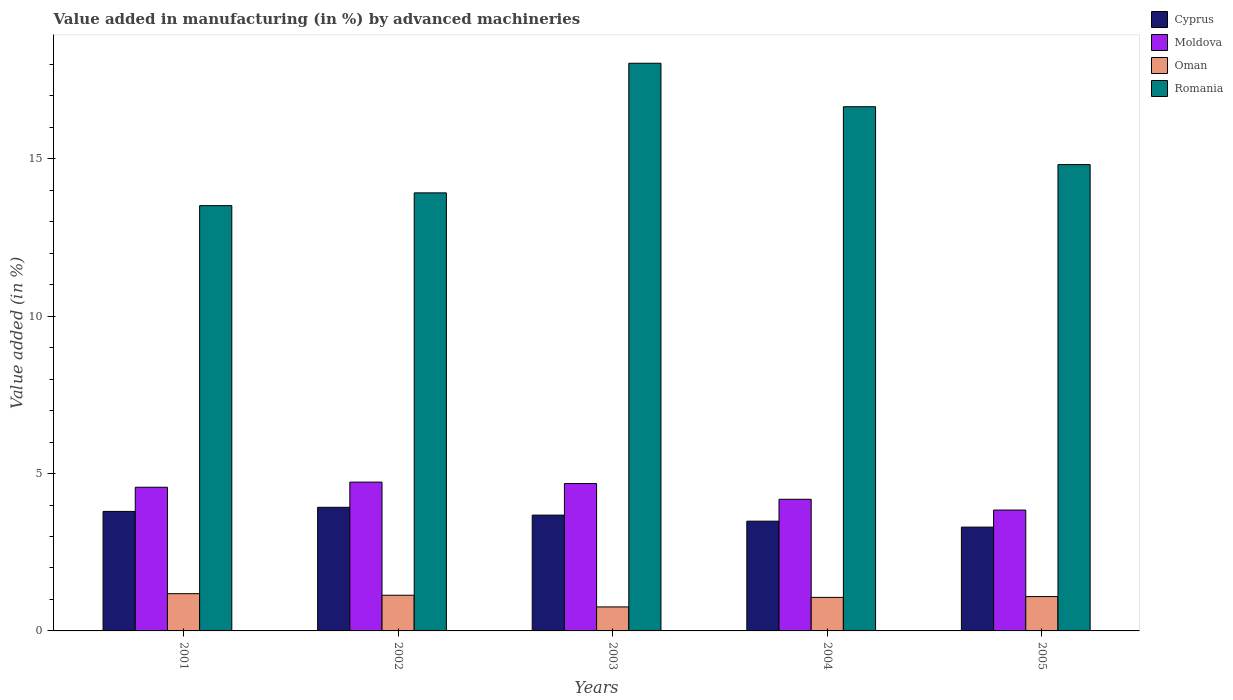How many different coloured bars are there?
Your answer should be compact. 4. Are the number of bars on each tick of the X-axis equal?
Your answer should be compact. Yes. How many bars are there on the 4th tick from the right?
Give a very brief answer. 4. What is the label of the 2nd group of bars from the left?
Offer a terse response. 2002. In how many cases, is the number of bars for a given year not equal to the number of legend labels?
Give a very brief answer. 0. What is the percentage of value added in manufacturing by advanced machineries in Romania in 2003?
Your answer should be very brief. 18.04. Across all years, what is the maximum percentage of value added in manufacturing by advanced machineries in Cyprus?
Give a very brief answer. 3.93. Across all years, what is the minimum percentage of value added in manufacturing by advanced machineries in Romania?
Provide a short and direct response. 13.51. In which year was the percentage of value added in manufacturing by advanced machineries in Cyprus minimum?
Ensure brevity in your answer.  2005. What is the total percentage of value added in manufacturing by advanced machineries in Moldova in the graph?
Make the answer very short. 22. What is the difference between the percentage of value added in manufacturing by advanced machineries in Moldova in 2004 and that in 2005?
Offer a very short reply. 0.34. What is the difference between the percentage of value added in manufacturing by advanced machineries in Oman in 2005 and the percentage of value added in manufacturing by advanced machineries in Moldova in 2001?
Your response must be concise. -3.47. What is the average percentage of value added in manufacturing by advanced machineries in Oman per year?
Give a very brief answer. 1.05. In the year 2004, what is the difference between the percentage of value added in manufacturing by advanced machineries in Moldova and percentage of value added in manufacturing by advanced machineries in Romania?
Your response must be concise. -12.47. In how many years, is the percentage of value added in manufacturing by advanced machineries in Moldova greater than 1 %?
Your response must be concise. 5. What is the ratio of the percentage of value added in manufacturing by advanced machineries in Moldova in 2003 to that in 2004?
Keep it short and to the point. 1.12. Is the percentage of value added in manufacturing by advanced machineries in Oman in 2001 less than that in 2003?
Provide a succinct answer. No. What is the difference between the highest and the second highest percentage of value added in manufacturing by advanced machineries in Romania?
Your answer should be compact. 1.38. What is the difference between the highest and the lowest percentage of value added in manufacturing by advanced machineries in Oman?
Provide a short and direct response. 0.42. In how many years, is the percentage of value added in manufacturing by advanced machineries in Oman greater than the average percentage of value added in manufacturing by advanced machineries in Oman taken over all years?
Provide a short and direct response. 4. Is the sum of the percentage of value added in manufacturing by advanced machineries in Romania in 2004 and 2005 greater than the maximum percentage of value added in manufacturing by advanced machineries in Cyprus across all years?
Your answer should be very brief. Yes. Is it the case that in every year, the sum of the percentage of value added in manufacturing by advanced machineries in Oman and percentage of value added in manufacturing by advanced machineries in Cyprus is greater than the sum of percentage of value added in manufacturing by advanced machineries in Romania and percentage of value added in manufacturing by advanced machineries in Moldova?
Your answer should be compact. No. What does the 2nd bar from the left in 2002 represents?
Your answer should be very brief. Moldova. What does the 2nd bar from the right in 2004 represents?
Your answer should be compact. Oman. How many bars are there?
Your response must be concise. 20. Are all the bars in the graph horizontal?
Keep it short and to the point. No. Are the values on the major ticks of Y-axis written in scientific E-notation?
Ensure brevity in your answer.  No. Does the graph contain grids?
Keep it short and to the point. No. How many legend labels are there?
Give a very brief answer. 4. What is the title of the graph?
Provide a short and direct response. Value added in manufacturing (in %) by advanced machineries. What is the label or title of the Y-axis?
Keep it short and to the point. Value added (in %). What is the Value added (in %) in Cyprus in 2001?
Give a very brief answer. 3.8. What is the Value added (in %) of Moldova in 2001?
Your answer should be very brief. 4.56. What is the Value added (in %) of Oman in 2001?
Offer a terse response. 1.18. What is the Value added (in %) in Romania in 2001?
Offer a terse response. 13.51. What is the Value added (in %) in Cyprus in 2002?
Your answer should be compact. 3.93. What is the Value added (in %) of Moldova in 2002?
Provide a succinct answer. 4.73. What is the Value added (in %) of Oman in 2002?
Offer a very short reply. 1.13. What is the Value added (in %) of Romania in 2002?
Keep it short and to the point. 13.92. What is the Value added (in %) in Cyprus in 2003?
Make the answer very short. 3.68. What is the Value added (in %) in Moldova in 2003?
Give a very brief answer. 4.68. What is the Value added (in %) in Oman in 2003?
Offer a very short reply. 0.76. What is the Value added (in %) of Romania in 2003?
Provide a short and direct response. 18.04. What is the Value added (in %) in Cyprus in 2004?
Your response must be concise. 3.49. What is the Value added (in %) in Moldova in 2004?
Keep it short and to the point. 4.18. What is the Value added (in %) in Oman in 2004?
Your answer should be compact. 1.07. What is the Value added (in %) of Romania in 2004?
Provide a short and direct response. 16.65. What is the Value added (in %) in Cyprus in 2005?
Give a very brief answer. 3.3. What is the Value added (in %) in Moldova in 2005?
Make the answer very short. 3.84. What is the Value added (in %) in Oman in 2005?
Offer a very short reply. 1.09. What is the Value added (in %) in Romania in 2005?
Your answer should be very brief. 14.82. Across all years, what is the maximum Value added (in %) in Cyprus?
Offer a very short reply. 3.93. Across all years, what is the maximum Value added (in %) in Moldova?
Your answer should be very brief. 4.73. Across all years, what is the maximum Value added (in %) in Oman?
Keep it short and to the point. 1.18. Across all years, what is the maximum Value added (in %) in Romania?
Your answer should be very brief. 18.04. Across all years, what is the minimum Value added (in %) in Cyprus?
Offer a terse response. 3.3. Across all years, what is the minimum Value added (in %) in Moldova?
Keep it short and to the point. 3.84. Across all years, what is the minimum Value added (in %) of Oman?
Offer a very short reply. 0.76. Across all years, what is the minimum Value added (in %) in Romania?
Offer a very short reply. 13.51. What is the total Value added (in %) of Cyprus in the graph?
Your answer should be very brief. 18.19. What is the total Value added (in %) in Moldova in the graph?
Offer a terse response. 22. What is the total Value added (in %) in Oman in the graph?
Offer a very short reply. 5.24. What is the total Value added (in %) of Romania in the graph?
Your answer should be compact. 76.94. What is the difference between the Value added (in %) of Cyprus in 2001 and that in 2002?
Your answer should be compact. -0.13. What is the difference between the Value added (in %) of Moldova in 2001 and that in 2002?
Provide a short and direct response. -0.16. What is the difference between the Value added (in %) of Romania in 2001 and that in 2002?
Provide a short and direct response. -0.41. What is the difference between the Value added (in %) in Cyprus in 2001 and that in 2003?
Make the answer very short. 0.12. What is the difference between the Value added (in %) in Moldova in 2001 and that in 2003?
Ensure brevity in your answer.  -0.12. What is the difference between the Value added (in %) of Oman in 2001 and that in 2003?
Offer a very short reply. 0.42. What is the difference between the Value added (in %) of Romania in 2001 and that in 2003?
Provide a succinct answer. -4.52. What is the difference between the Value added (in %) in Cyprus in 2001 and that in 2004?
Offer a terse response. 0.31. What is the difference between the Value added (in %) in Moldova in 2001 and that in 2004?
Your answer should be compact. 0.38. What is the difference between the Value added (in %) of Oman in 2001 and that in 2004?
Your answer should be compact. 0.12. What is the difference between the Value added (in %) of Romania in 2001 and that in 2004?
Your answer should be compact. -3.14. What is the difference between the Value added (in %) in Cyprus in 2001 and that in 2005?
Offer a very short reply. 0.5. What is the difference between the Value added (in %) of Moldova in 2001 and that in 2005?
Make the answer very short. 0.72. What is the difference between the Value added (in %) in Oman in 2001 and that in 2005?
Give a very brief answer. 0.09. What is the difference between the Value added (in %) of Romania in 2001 and that in 2005?
Give a very brief answer. -1.3. What is the difference between the Value added (in %) in Cyprus in 2002 and that in 2003?
Your response must be concise. 0.25. What is the difference between the Value added (in %) in Moldova in 2002 and that in 2003?
Give a very brief answer. 0.04. What is the difference between the Value added (in %) in Oman in 2002 and that in 2003?
Ensure brevity in your answer.  0.37. What is the difference between the Value added (in %) of Romania in 2002 and that in 2003?
Ensure brevity in your answer.  -4.12. What is the difference between the Value added (in %) of Cyprus in 2002 and that in 2004?
Offer a very short reply. 0.44. What is the difference between the Value added (in %) of Moldova in 2002 and that in 2004?
Your answer should be compact. 0.55. What is the difference between the Value added (in %) of Oman in 2002 and that in 2004?
Your answer should be very brief. 0.07. What is the difference between the Value added (in %) in Romania in 2002 and that in 2004?
Offer a terse response. -2.74. What is the difference between the Value added (in %) in Cyprus in 2002 and that in 2005?
Give a very brief answer. 0.63. What is the difference between the Value added (in %) in Moldova in 2002 and that in 2005?
Make the answer very short. 0.89. What is the difference between the Value added (in %) in Oman in 2002 and that in 2005?
Your answer should be compact. 0.04. What is the difference between the Value added (in %) of Romania in 2002 and that in 2005?
Your answer should be very brief. -0.9. What is the difference between the Value added (in %) of Cyprus in 2003 and that in 2004?
Offer a terse response. 0.19. What is the difference between the Value added (in %) of Moldova in 2003 and that in 2004?
Ensure brevity in your answer.  0.5. What is the difference between the Value added (in %) of Oman in 2003 and that in 2004?
Keep it short and to the point. -0.3. What is the difference between the Value added (in %) in Romania in 2003 and that in 2004?
Offer a terse response. 1.38. What is the difference between the Value added (in %) of Cyprus in 2003 and that in 2005?
Offer a terse response. 0.38. What is the difference between the Value added (in %) in Moldova in 2003 and that in 2005?
Keep it short and to the point. 0.84. What is the difference between the Value added (in %) of Oman in 2003 and that in 2005?
Provide a succinct answer. -0.33. What is the difference between the Value added (in %) of Romania in 2003 and that in 2005?
Provide a succinct answer. 3.22. What is the difference between the Value added (in %) in Cyprus in 2004 and that in 2005?
Your response must be concise. 0.19. What is the difference between the Value added (in %) of Moldova in 2004 and that in 2005?
Ensure brevity in your answer.  0.34. What is the difference between the Value added (in %) of Oman in 2004 and that in 2005?
Provide a succinct answer. -0.03. What is the difference between the Value added (in %) in Romania in 2004 and that in 2005?
Give a very brief answer. 1.84. What is the difference between the Value added (in %) in Cyprus in 2001 and the Value added (in %) in Moldova in 2002?
Offer a very short reply. -0.93. What is the difference between the Value added (in %) in Cyprus in 2001 and the Value added (in %) in Oman in 2002?
Offer a terse response. 2.66. What is the difference between the Value added (in %) of Cyprus in 2001 and the Value added (in %) of Romania in 2002?
Ensure brevity in your answer.  -10.12. What is the difference between the Value added (in %) in Moldova in 2001 and the Value added (in %) in Oman in 2002?
Give a very brief answer. 3.43. What is the difference between the Value added (in %) of Moldova in 2001 and the Value added (in %) of Romania in 2002?
Your response must be concise. -9.35. What is the difference between the Value added (in %) in Oman in 2001 and the Value added (in %) in Romania in 2002?
Make the answer very short. -12.73. What is the difference between the Value added (in %) in Cyprus in 2001 and the Value added (in %) in Moldova in 2003?
Your answer should be compact. -0.89. What is the difference between the Value added (in %) in Cyprus in 2001 and the Value added (in %) in Oman in 2003?
Keep it short and to the point. 3.03. What is the difference between the Value added (in %) in Cyprus in 2001 and the Value added (in %) in Romania in 2003?
Ensure brevity in your answer.  -14.24. What is the difference between the Value added (in %) in Moldova in 2001 and the Value added (in %) in Oman in 2003?
Your response must be concise. 3.8. What is the difference between the Value added (in %) of Moldova in 2001 and the Value added (in %) of Romania in 2003?
Offer a very short reply. -13.47. What is the difference between the Value added (in %) in Oman in 2001 and the Value added (in %) in Romania in 2003?
Your answer should be very brief. -16.85. What is the difference between the Value added (in %) of Cyprus in 2001 and the Value added (in %) of Moldova in 2004?
Your response must be concise. -0.39. What is the difference between the Value added (in %) of Cyprus in 2001 and the Value added (in %) of Oman in 2004?
Keep it short and to the point. 2.73. What is the difference between the Value added (in %) of Cyprus in 2001 and the Value added (in %) of Romania in 2004?
Offer a very short reply. -12.86. What is the difference between the Value added (in %) of Moldova in 2001 and the Value added (in %) of Oman in 2004?
Provide a succinct answer. 3.5. What is the difference between the Value added (in %) of Moldova in 2001 and the Value added (in %) of Romania in 2004?
Provide a short and direct response. -12.09. What is the difference between the Value added (in %) of Oman in 2001 and the Value added (in %) of Romania in 2004?
Your response must be concise. -15.47. What is the difference between the Value added (in %) in Cyprus in 2001 and the Value added (in %) in Moldova in 2005?
Offer a very short reply. -0.04. What is the difference between the Value added (in %) in Cyprus in 2001 and the Value added (in %) in Oman in 2005?
Make the answer very short. 2.71. What is the difference between the Value added (in %) of Cyprus in 2001 and the Value added (in %) of Romania in 2005?
Provide a short and direct response. -11.02. What is the difference between the Value added (in %) in Moldova in 2001 and the Value added (in %) in Oman in 2005?
Give a very brief answer. 3.47. What is the difference between the Value added (in %) in Moldova in 2001 and the Value added (in %) in Romania in 2005?
Provide a succinct answer. -10.25. What is the difference between the Value added (in %) of Oman in 2001 and the Value added (in %) of Romania in 2005?
Provide a succinct answer. -13.63. What is the difference between the Value added (in %) in Cyprus in 2002 and the Value added (in %) in Moldova in 2003?
Offer a very short reply. -0.76. What is the difference between the Value added (in %) in Cyprus in 2002 and the Value added (in %) in Oman in 2003?
Make the answer very short. 3.17. What is the difference between the Value added (in %) of Cyprus in 2002 and the Value added (in %) of Romania in 2003?
Offer a terse response. -14.11. What is the difference between the Value added (in %) of Moldova in 2002 and the Value added (in %) of Oman in 2003?
Keep it short and to the point. 3.97. What is the difference between the Value added (in %) in Moldova in 2002 and the Value added (in %) in Romania in 2003?
Ensure brevity in your answer.  -13.31. What is the difference between the Value added (in %) of Oman in 2002 and the Value added (in %) of Romania in 2003?
Give a very brief answer. -16.9. What is the difference between the Value added (in %) of Cyprus in 2002 and the Value added (in %) of Moldova in 2004?
Your response must be concise. -0.26. What is the difference between the Value added (in %) of Cyprus in 2002 and the Value added (in %) of Oman in 2004?
Make the answer very short. 2.86. What is the difference between the Value added (in %) in Cyprus in 2002 and the Value added (in %) in Romania in 2004?
Ensure brevity in your answer.  -12.73. What is the difference between the Value added (in %) of Moldova in 2002 and the Value added (in %) of Oman in 2004?
Offer a very short reply. 3.66. What is the difference between the Value added (in %) of Moldova in 2002 and the Value added (in %) of Romania in 2004?
Your answer should be very brief. -11.93. What is the difference between the Value added (in %) of Oman in 2002 and the Value added (in %) of Romania in 2004?
Your answer should be compact. -15.52. What is the difference between the Value added (in %) of Cyprus in 2002 and the Value added (in %) of Moldova in 2005?
Offer a very short reply. 0.09. What is the difference between the Value added (in %) in Cyprus in 2002 and the Value added (in %) in Oman in 2005?
Ensure brevity in your answer.  2.84. What is the difference between the Value added (in %) of Cyprus in 2002 and the Value added (in %) of Romania in 2005?
Offer a very short reply. -10.89. What is the difference between the Value added (in %) in Moldova in 2002 and the Value added (in %) in Oman in 2005?
Provide a short and direct response. 3.64. What is the difference between the Value added (in %) of Moldova in 2002 and the Value added (in %) of Romania in 2005?
Your response must be concise. -10.09. What is the difference between the Value added (in %) of Oman in 2002 and the Value added (in %) of Romania in 2005?
Provide a short and direct response. -13.68. What is the difference between the Value added (in %) of Cyprus in 2003 and the Value added (in %) of Moldova in 2004?
Make the answer very short. -0.5. What is the difference between the Value added (in %) in Cyprus in 2003 and the Value added (in %) in Oman in 2004?
Your response must be concise. 2.61. What is the difference between the Value added (in %) of Cyprus in 2003 and the Value added (in %) of Romania in 2004?
Provide a succinct answer. -12.97. What is the difference between the Value added (in %) of Moldova in 2003 and the Value added (in %) of Oman in 2004?
Your response must be concise. 3.62. What is the difference between the Value added (in %) of Moldova in 2003 and the Value added (in %) of Romania in 2004?
Provide a short and direct response. -11.97. What is the difference between the Value added (in %) in Oman in 2003 and the Value added (in %) in Romania in 2004?
Ensure brevity in your answer.  -15.89. What is the difference between the Value added (in %) of Cyprus in 2003 and the Value added (in %) of Moldova in 2005?
Keep it short and to the point. -0.16. What is the difference between the Value added (in %) of Cyprus in 2003 and the Value added (in %) of Oman in 2005?
Make the answer very short. 2.59. What is the difference between the Value added (in %) of Cyprus in 2003 and the Value added (in %) of Romania in 2005?
Your response must be concise. -11.14. What is the difference between the Value added (in %) in Moldova in 2003 and the Value added (in %) in Oman in 2005?
Ensure brevity in your answer.  3.59. What is the difference between the Value added (in %) of Moldova in 2003 and the Value added (in %) of Romania in 2005?
Provide a succinct answer. -10.13. What is the difference between the Value added (in %) in Oman in 2003 and the Value added (in %) in Romania in 2005?
Your answer should be compact. -14.05. What is the difference between the Value added (in %) of Cyprus in 2004 and the Value added (in %) of Moldova in 2005?
Make the answer very short. -0.35. What is the difference between the Value added (in %) of Cyprus in 2004 and the Value added (in %) of Oman in 2005?
Offer a terse response. 2.4. What is the difference between the Value added (in %) in Cyprus in 2004 and the Value added (in %) in Romania in 2005?
Keep it short and to the point. -11.33. What is the difference between the Value added (in %) of Moldova in 2004 and the Value added (in %) of Oman in 2005?
Give a very brief answer. 3.09. What is the difference between the Value added (in %) in Moldova in 2004 and the Value added (in %) in Romania in 2005?
Offer a terse response. -10.63. What is the difference between the Value added (in %) of Oman in 2004 and the Value added (in %) of Romania in 2005?
Give a very brief answer. -13.75. What is the average Value added (in %) of Cyprus per year?
Give a very brief answer. 3.64. What is the average Value added (in %) in Moldova per year?
Provide a succinct answer. 4.4. What is the average Value added (in %) in Oman per year?
Offer a very short reply. 1.05. What is the average Value added (in %) of Romania per year?
Offer a terse response. 15.39. In the year 2001, what is the difference between the Value added (in %) of Cyprus and Value added (in %) of Moldova?
Your response must be concise. -0.77. In the year 2001, what is the difference between the Value added (in %) in Cyprus and Value added (in %) in Oman?
Offer a very short reply. 2.61. In the year 2001, what is the difference between the Value added (in %) in Cyprus and Value added (in %) in Romania?
Offer a terse response. -9.71. In the year 2001, what is the difference between the Value added (in %) of Moldova and Value added (in %) of Oman?
Keep it short and to the point. 3.38. In the year 2001, what is the difference between the Value added (in %) in Moldova and Value added (in %) in Romania?
Make the answer very short. -8.95. In the year 2001, what is the difference between the Value added (in %) in Oman and Value added (in %) in Romania?
Your response must be concise. -12.33. In the year 2002, what is the difference between the Value added (in %) of Cyprus and Value added (in %) of Moldova?
Offer a very short reply. -0.8. In the year 2002, what is the difference between the Value added (in %) in Cyprus and Value added (in %) in Oman?
Your response must be concise. 2.79. In the year 2002, what is the difference between the Value added (in %) in Cyprus and Value added (in %) in Romania?
Make the answer very short. -9.99. In the year 2002, what is the difference between the Value added (in %) in Moldova and Value added (in %) in Oman?
Offer a terse response. 3.59. In the year 2002, what is the difference between the Value added (in %) of Moldova and Value added (in %) of Romania?
Make the answer very short. -9.19. In the year 2002, what is the difference between the Value added (in %) of Oman and Value added (in %) of Romania?
Provide a short and direct response. -12.78. In the year 2003, what is the difference between the Value added (in %) of Cyprus and Value added (in %) of Moldova?
Offer a terse response. -1. In the year 2003, what is the difference between the Value added (in %) in Cyprus and Value added (in %) in Oman?
Your response must be concise. 2.92. In the year 2003, what is the difference between the Value added (in %) of Cyprus and Value added (in %) of Romania?
Make the answer very short. -14.36. In the year 2003, what is the difference between the Value added (in %) in Moldova and Value added (in %) in Oman?
Provide a succinct answer. 3.92. In the year 2003, what is the difference between the Value added (in %) of Moldova and Value added (in %) of Romania?
Your answer should be very brief. -13.35. In the year 2003, what is the difference between the Value added (in %) in Oman and Value added (in %) in Romania?
Keep it short and to the point. -17.27. In the year 2004, what is the difference between the Value added (in %) in Cyprus and Value added (in %) in Moldova?
Keep it short and to the point. -0.7. In the year 2004, what is the difference between the Value added (in %) of Cyprus and Value added (in %) of Oman?
Your answer should be compact. 2.42. In the year 2004, what is the difference between the Value added (in %) in Cyprus and Value added (in %) in Romania?
Keep it short and to the point. -13.17. In the year 2004, what is the difference between the Value added (in %) of Moldova and Value added (in %) of Oman?
Ensure brevity in your answer.  3.12. In the year 2004, what is the difference between the Value added (in %) in Moldova and Value added (in %) in Romania?
Your answer should be compact. -12.47. In the year 2004, what is the difference between the Value added (in %) of Oman and Value added (in %) of Romania?
Keep it short and to the point. -15.59. In the year 2005, what is the difference between the Value added (in %) in Cyprus and Value added (in %) in Moldova?
Ensure brevity in your answer.  -0.54. In the year 2005, what is the difference between the Value added (in %) in Cyprus and Value added (in %) in Oman?
Ensure brevity in your answer.  2.21. In the year 2005, what is the difference between the Value added (in %) in Cyprus and Value added (in %) in Romania?
Your response must be concise. -11.52. In the year 2005, what is the difference between the Value added (in %) of Moldova and Value added (in %) of Oman?
Provide a succinct answer. 2.75. In the year 2005, what is the difference between the Value added (in %) of Moldova and Value added (in %) of Romania?
Your response must be concise. -10.98. In the year 2005, what is the difference between the Value added (in %) in Oman and Value added (in %) in Romania?
Keep it short and to the point. -13.73. What is the ratio of the Value added (in %) in Cyprus in 2001 to that in 2002?
Ensure brevity in your answer.  0.97. What is the ratio of the Value added (in %) of Moldova in 2001 to that in 2002?
Provide a succinct answer. 0.97. What is the ratio of the Value added (in %) of Oman in 2001 to that in 2002?
Provide a succinct answer. 1.04. What is the ratio of the Value added (in %) of Romania in 2001 to that in 2002?
Your response must be concise. 0.97. What is the ratio of the Value added (in %) of Cyprus in 2001 to that in 2003?
Offer a terse response. 1.03. What is the ratio of the Value added (in %) in Moldova in 2001 to that in 2003?
Give a very brief answer. 0.97. What is the ratio of the Value added (in %) of Oman in 2001 to that in 2003?
Your response must be concise. 1.55. What is the ratio of the Value added (in %) of Romania in 2001 to that in 2003?
Offer a terse response. 0.75. What is the ratio of the Value added (in %) in Cyprus in 2001 to that in 2004?
Offer a terse response. 1.09. What is the ratio of the Value added (in %) in Moldova in 2001 to that in 2004?
Make the answer very short. 1.09. What is the ratio of the Value added (in %) in Oman in 2001 to that in 2004?
Your response must be concise. 1.11. What is the ratio of the Value added (in %) of Romania in 2001 to that in 2004?
Offer a terse response. 0.81. What is the ratio of the Value added (in %) of Cyprus in 2001 to that in 2005?
Provide a succinct answer. 1.15. What is the ratio of the Value added (in %) in Moldova in 2001 to that in 2005?
Provide a succinct answer. 1.19. What is the ratio of the Value added (in %) of Oman in 2001 to that in 2005?
Provide a short and direct response. 1.08. What is the ratio of the Value added (in %) in Romania in 2001 to that in 2005?
Provide a short and direct response. 0.91. What is the ratio of the Value added (in %) of Cyprus in 2002 to that in 2003?
Ensure brevity in your answer.  1.07. What is the ratio of the Value added (in %) in Moldova in 2002 to that in 2003?
Provide a succinct answer. 1.01. What is the ratio of the Value added (in %) of Oman in 2002 to that in 2003?
Keep it short and to the point. 1.49. What is the ratio of the Value added (in %) of Romania in 2002 to that in 2003?
Make the answer very short. 0.77. What is the ratio of the Value added (in %) in Cyprus in 2002 to that in 2004?
Keep it short and to the point. 1.13. What is the ratio of the Value added (in %) of Moldova in 2002 to that in 2004?
Provide a succinct answer. 1.13. What is the ratio of the Value added (in %) in Oman in 2002 to that in 2004?
Keep it short and to the point. 1.06. What is the ratio of the Value added (in %) in Romania in 2002 to that in 2004?
Provide a succinct answer. 0.84. What is the ratio of the Value added (in %) in Cyprus in 2002 to that in 2005?
Provide a short and direct response. 1.19. What is the ratio of the Value added (in %) of Moldova in 2002 to that in 2005?
Offer a very short reply. 1.23. What is the ratio of the Value added (in %) of Oman in 2002 to that in 2005?
Keep it short and to the point. 1.04. What is the ratio of the Value added (in %) in Romania in 2002 to that in 2005?
Offer a terse response. 0.94. What is the ratio of the Value added (in %) in Cyprus in 2003 to that in 2004?
Make the answer very short. 1.06. What is the ratio of the Value added (in %) in Moldova in 2003 to that in 2004?
Your response must be concise. 1.12. What is the ratio of the Value added (in %) of Oman in 2003 to that in 2004?
Offer a terse response. 0.72. What is the ratio of the Value added (in %) of Romania in 2003 to that in 2004?
Give a very brief answer. 1.08. What is the ratio of the Value added (in %) in Cyprus in 2003 to that in 2005?
Make the answer very short. 1.12. What is the ratio of the Value added (in %) in Moldova in 2003 to that in 2005?
Offer a terse response. 1.22. What is the ratio of the Value added (in %) in Oman in 2003 to that in 2005?
Offer a terse response. 0.7. What is the ratio of the Value added (in %) in Romania in 2003 to that in 2005?
Your response must be concise. 1.22. What is the ratio of the Value added (in %) in Cyprus in 2004 to that in 2005?
Your answer should be very brief. 1.06. What is the ratio of the Value added (in %) in Moldova in 2004 to that in 2005?
Offer a terse response. 1.09. What is the ratio of the Value added (in %) of Oman in 2004 to that in 2005?
Offer a terse response. 0.98. What is the ratio of the Value added (in %) in Romania in 2004 to that in 2005?
Keep it short and to the point. 1.12. What is the difference between the highest and the second highest Value added (in %) in Cyprus?
Keep it short and to the point. 0.13. What is the difference between the highest and the second highest Value added (in %) of Moldova?
Give a very brief answer. 0.04. What is the difference between the highest and the second highest Value added (in %) in Oman?
Provide a short and direct response. 0.05. What is the difference between the highest and the second highest Value added (in %) of Romania?
Your answer should be compact. 1.38. What is the difference between the highest and the lowest Value added (in %) in Cyprus?
Offer a terse response. 0.63. What is the difference between the highest and the lowest Value added (in %) in Moldova?
Offer a very short reply. 0.89. What is the difference between the highest and the lowest Value added (in %) in Oman?
Your response must be concise. 0.42. What is the difference between the highest and the lowest Value added (in %) of Romania?
Offer a very short reply. 4.52. 